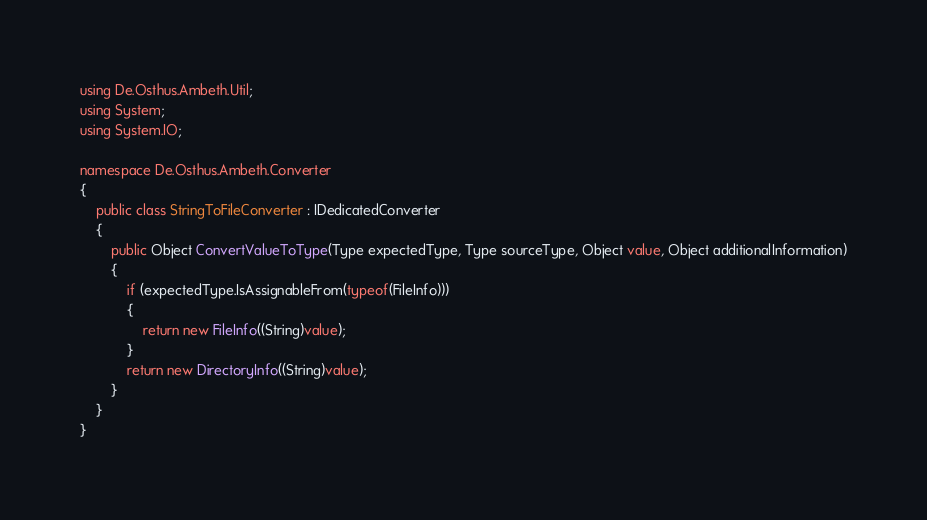<code> <loc_0><loc_0><loc_500><loc_500><_C#_>using De.Osthus.Ambeth.Util;
using System;
using System.IO;

namespace De.Osthus.Ambeth.Converter
{
    public class StringToFileConverter : IDedicatedConverter
    {
        public Object ConvertValueToType(Type expectedType, Type sourceType, Object value, Object additionalInformation)
        {
            if (expectedType.IsAssignableFrom(typeof(FileInfo)))
            {
                return new FileInfo((String)value);
            }
            return new DirectoryInfo((String)value);
        }
    }
}</code> 